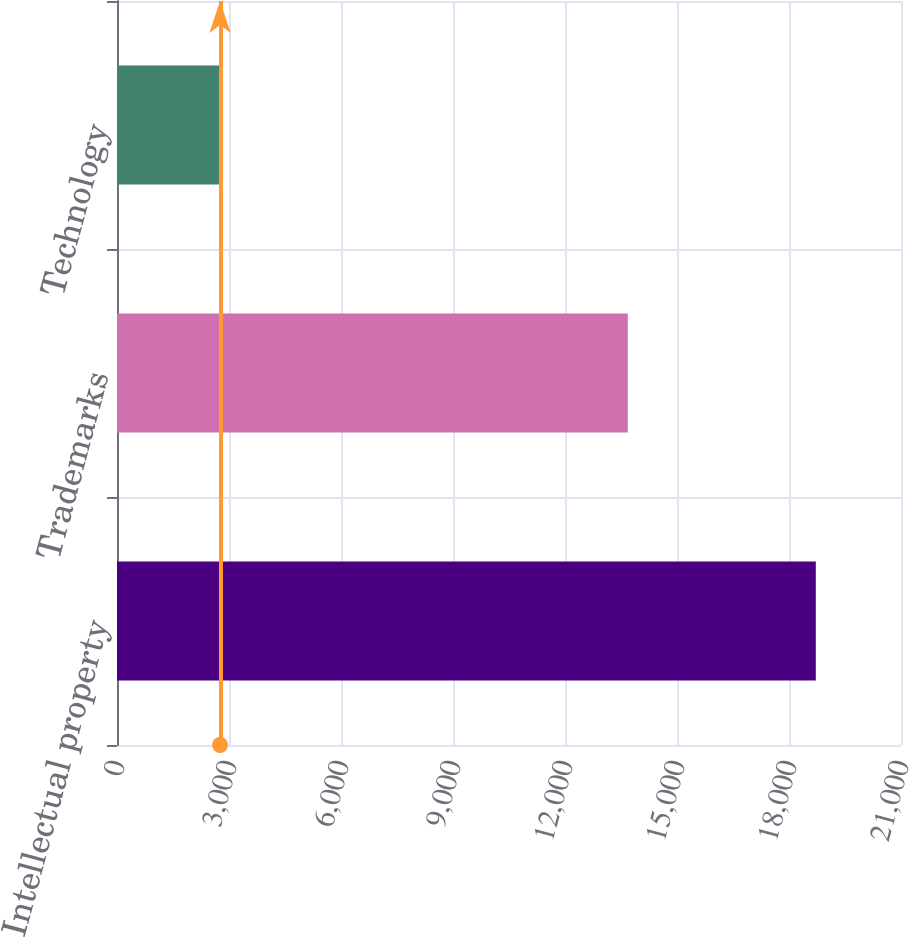<chart> <loc_0><loc_0><loc_500><loc_500><bar_chart><fcel>Intellectual property<fcel>Trademarks<fcel>Technology<nl><fcel>18718<fcel>13682<fcel>2760<nl></chart> 